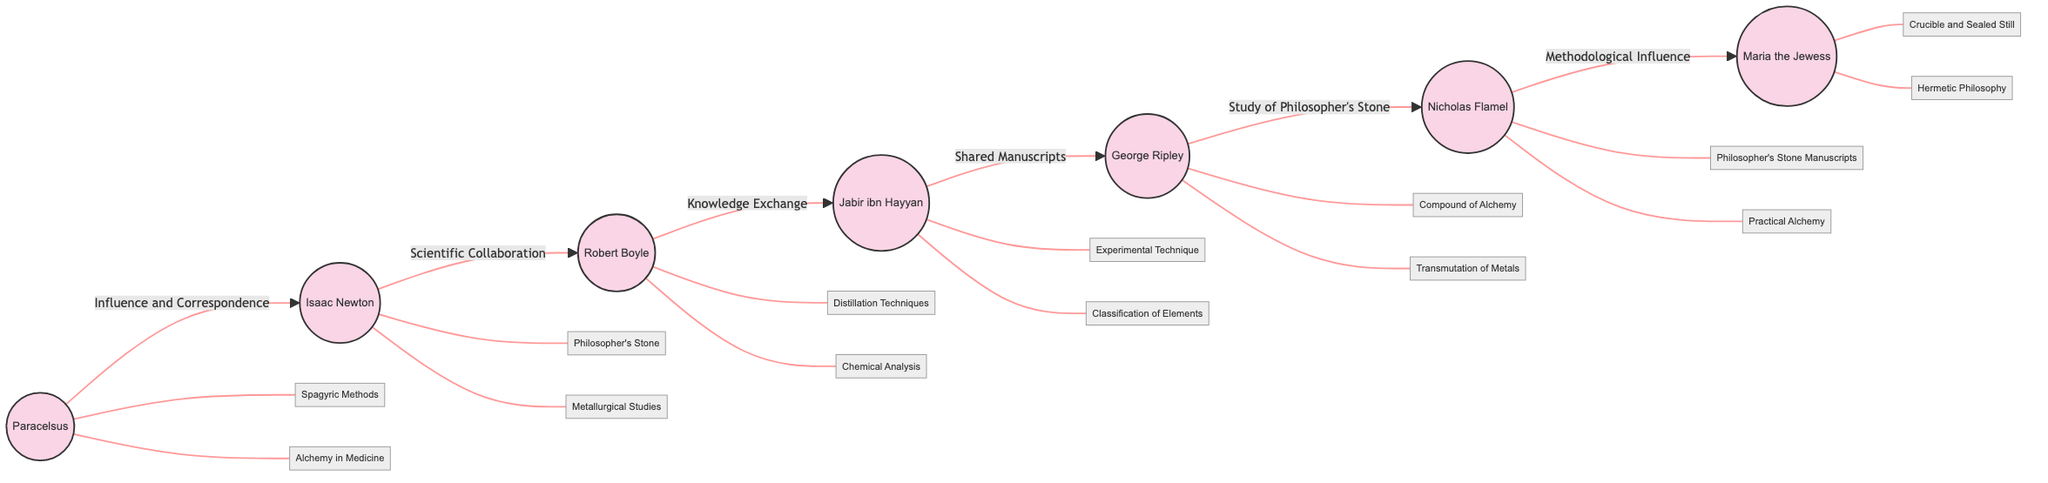What is the total number of alchemists represented in the diagram? The diagram includes a list of nodes, each representing an alchemist. Counting these nodes gives us a total of 7 alchemists.
Answer: 7 Who has a contribution related to the Philosopher's Stone? By examining the contributions linked to each alchemist, it is observed that both Isaac Newton and Nicholas Flamel are associated with the Philosopher's Stone through their respective contributions.
Answer: Isaac Newton, Nicholas Flamel Which alchemist is connected to George Ripley by shared manuscripts? The edges between the nodes indicate relationships. The edge from Jabir ibn Hayyan to George Ripley specifies that they have a connection due to shared manuscripts.
Answer: Jabir ibn Hayyan What is the relationship between Paracelsus and Isaac Newton? The relationship is defined by the edge linking Paracelsus and Isaac Newton, labeled as "Influence and Correspondence." This indicates that Paracelsus influenced Newton through correspondence.
Answer: Influence and Correspondence How many different contributions are listed for Robert Boyle? Looking at the contributions associated with Robert Boyle in the diagram, we find two distinct contributions: "Refinement of Distillation Techniques" and "Alchemy in Chemical Analysis," which totals to two contributions.
Answer: 2 Which alchemist is last in the "influence" chain amongst the others? Following the diagram's edges sequentially from Paracelsus through to Maria the Jewess shows that Maria the Jewess is the last alchemist affected by influences stemming from the earliest figure in the chain, Paracelsus.
Answer: Maria the Jewess What technique is associated with Maria the Jewess? Upon examining the contributions linked to Maria the Jewess, it is evident that she is credited with the invention of the "Crucible and Sealed Still," which signifies her contribution to alchemical techniques.
Answer: Crucible and Sealed Still Which alchemist’s work focused on experimental techniques? By evaluating the contributions listed, Jabir ibn Hayyan is indicated as the alchemist known for introducing "Experimental Technique" in his work.
Answer: Jabir ibn Hayyan What type of relationship connects Robert Boyle and Jabir ibn Hayyan? The edge between Robert Boyle and Jabir ibn Hayyan specifies the type of relationship as "Knowledge Exchange," indicating that their connection revolved around the sharing of knowledge in alchemy.
Answer: Knowledge Exchange 